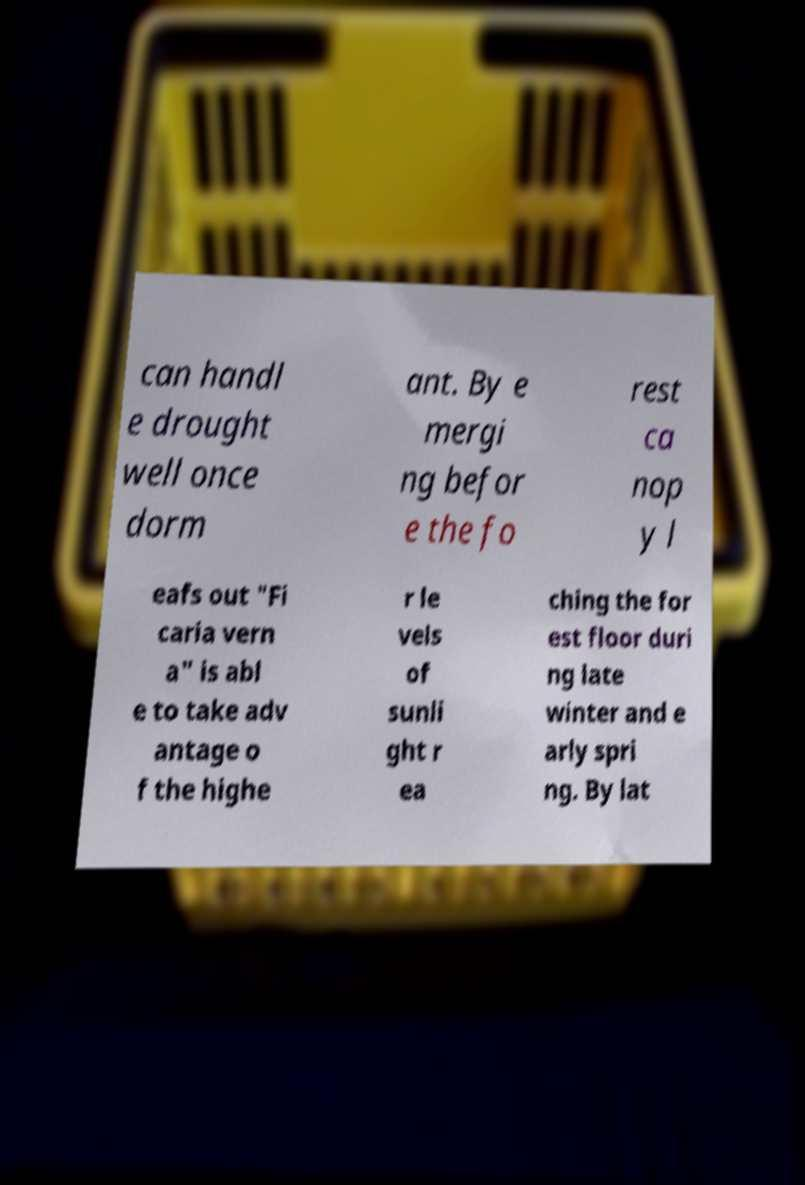Could you extract and type out the text from this image? can handl e drought well once dorm ant. By e mergi ng befor e the fo rest ca nop y l eafs out "Fi caria vern a" is abl e to take adv antage o f the highe r le vels of sunli ght r ea ching the for est floor duri ng late winter and e arly spri ng. By lat 